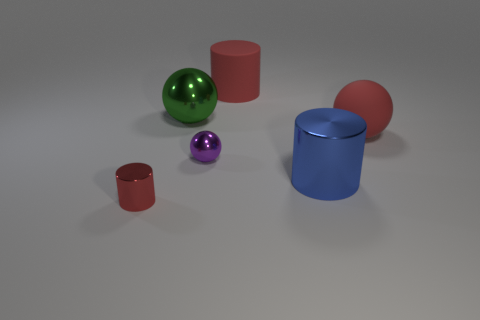There is another metal object that is the same shape as the blue object; what color is it?
Give a very brief answer. Red. Are there the same number of red shiny cylinders to the left of the large red rubber cylinder and big blue metallic things in front of the blue thing?
Your answer should be very brief. No. What material is the tiny purple thing?
Offer a very short reply. Metal. There is a metallic sphere that is the same size as the red matte sphere; what color is it?
Provide a short and direct response. Green. There is a big cylinder that is behind the big green shiny thing; is there a rubber ball left of it?
Provide a short and direct response. No. How many spheres are either large shiny things or blue things?
Your answer should be very brief. 1. What size is the cylinder in front of the large cylinder in front of the large ball that is to the right of the large metal cylinder?
Provide a succinct answer. Small. Are there any big blue things on the left side of the big matte cylinder?
Give a very brief answer. No. There is a metal thing that is the same color as the matte sphere; what is its shape?
Provide a succinct answer. Cylinder. How many objects are red objects that are behind the small shiny cylinder or tiny brown matte spheres?
Offer a very short reply. 2. 